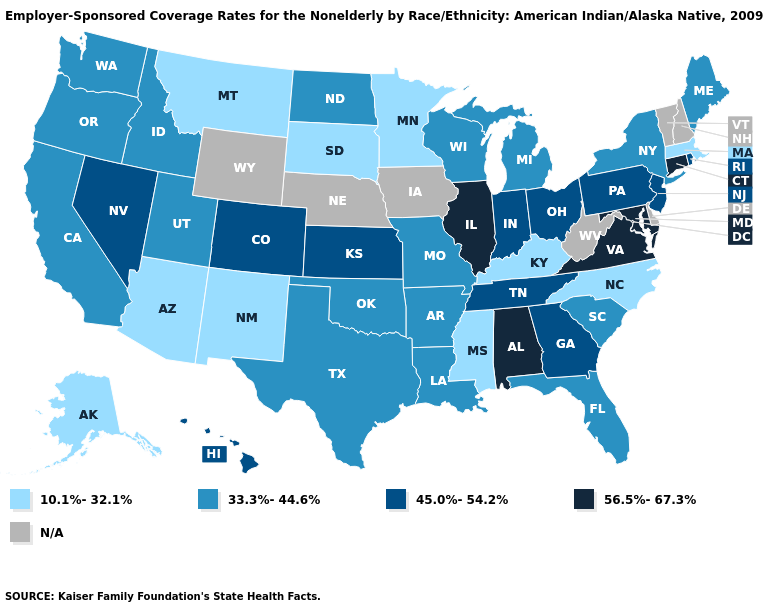What is the value of North Carolina?
Quick response, please. 10.1%-32.1%. What is the value of Nevada?
Quick response, please. 45.0%-54.2%. What is the value of Kansas?
Give a very brief answer. 45.0%-54.2%. Is the legend a continuous bar?
Be succinct. No. Which states hav the highest value in the West?
Short answer required. Colorado, Hawaii, Nevada. Does the map have missing data?
Concise answer only. Yes. Does Alaska have the highest value in the USA?
Answer briefly. No. Name the states that have a value in the range 10.1%-32.1%?
Answer briefly. Alaska, Arizona, Kentucky, Massachusetts, Minnesota, Mississippi, Montana, New Mexico, North Carolina, South Dakota. Does Illinois have the highest value in the MidWest?
Be succinct. Yes. What is the value of Louisiana?
Give a very brief answer. 33.3%-44.6%. What is the value of New Hampshire?
Keep it brief. N/A. What is the highest value in the South ?
Answer briefly. 56.5%-67.3%. Is the legend a continuous bar?
Concise answer only. No. Does Louisiana have the highest value in the USA?
Be succinct. No. 